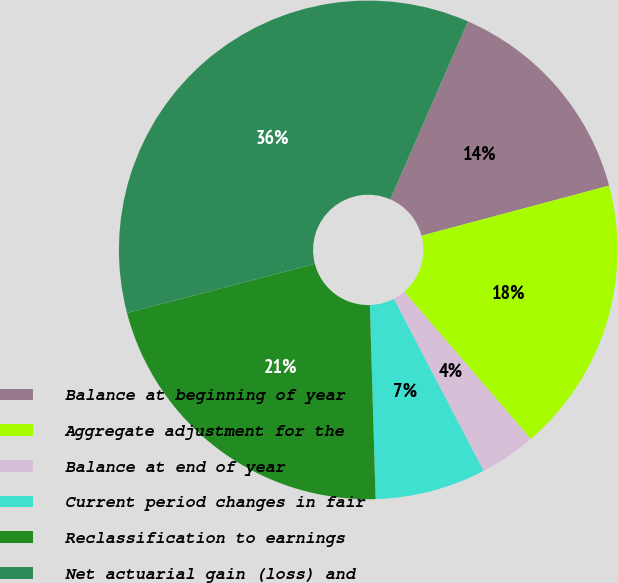<chart> <loc_0><loc_0><loc_500><loc_500><pie_chart><fcel>Balance at beginning of year<fcel>Aggregate adjustment for the<fcel>Balance at end of year<fcel>Current period changes in fair<fcel>Reclassification to earnings<fcel>Net actuarial gain (loss) and<nl><fcel>14.3%<fcel>17.85%<fcel>3.64%<fcel>7.19%<fcel>21.4%<fcel>35.62%<nl></chart> 